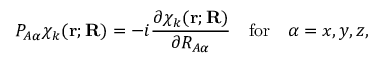Convert formula to latex. <formula><loc_0><loc_0><loc_500><loc_500>P _ { A \alpha } \chi _ { k } ( r ; R ) = - i { \frac { \partial \chi _ { k } ( r ; R ) } { \partial R _ { A \alpha } } } \quad f o r \quad \alpha = x , y , z ,</formula> 